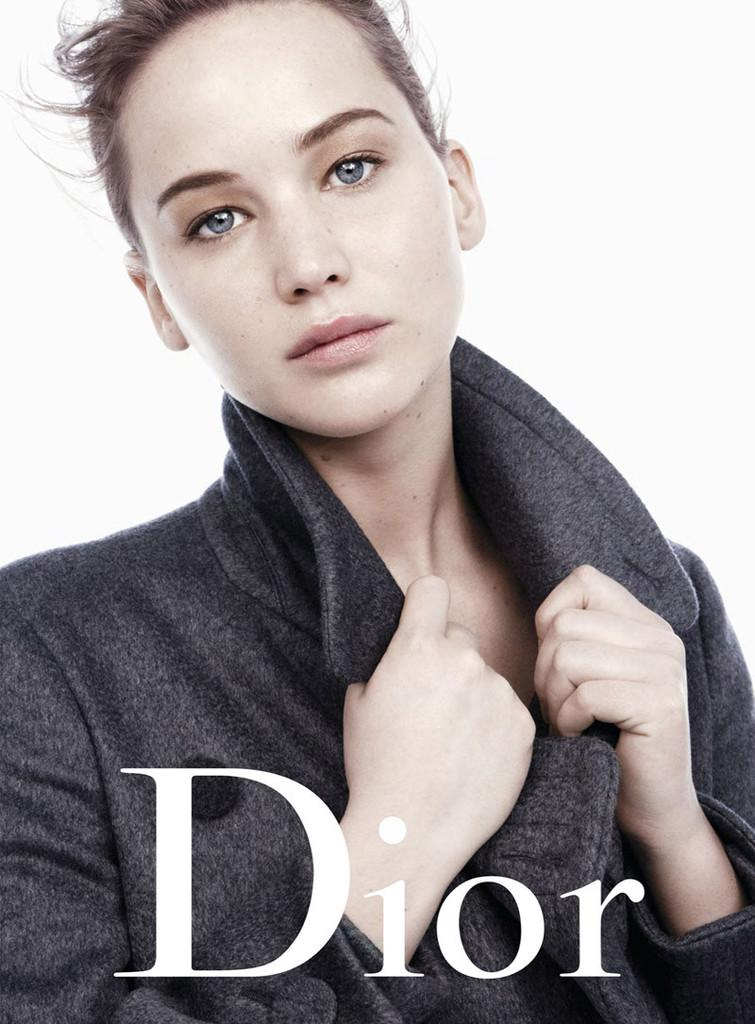What type of image is being described? The image is a magazine cover photo. Who is featured in the image? There is a woman in the image. What is the woman holding? The woman is holding a jacket. Where can text be found in the image? There is text at the bottom of the image. What color is the background of the image? The background of the image is white. What type of ice can be seen melting in the bedroom in the image? There is no ice or bedroom present in the image; it features a woman holding a jacket on a white background with text at the bottom. 